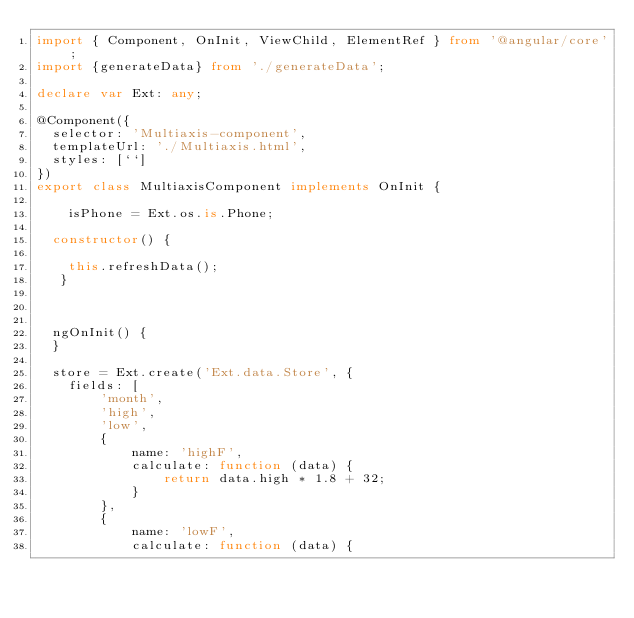<code> <loc_0><loc_0><loc_500><loc_500><_TypeScript_>import { Component, OnInit, ViewChild, ElementRef } from '@angular/core';
import {generateData} from './generateData';

declare var Ext: any;

@Component({
  selector: 'Multiaxis-component',
  templateUrl: './Multiaxis.html',
  styles: [``]
})
export class MultiaxisComponent implements OnInit {

    isPhone = Ext.os.is.Phone;

  constructor() {

    this.refreshData();
   }



  ngOnInit() {
  }

  store = Ext.create('Ext.data.Store', {
    fields: [
        'month',
        'high',
        'low',
        {
            name: 'highF',
            calculate: function (data) {
                return data.high * 1.8 + 32;
            }
        },
        {
            name: 'lowF',
            calculate: function (data) {</code> 